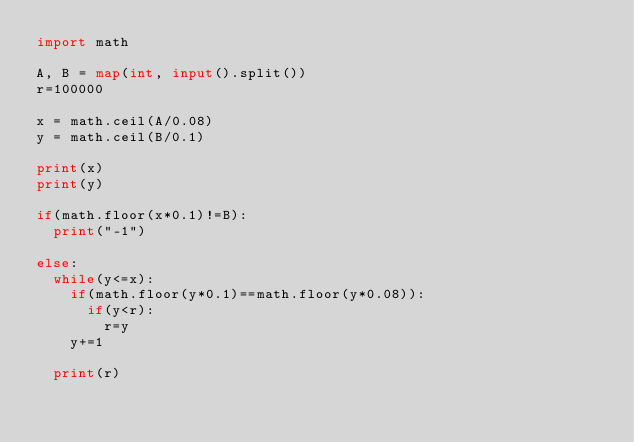<code> <loc_0><loc_0><loc_500><loc_500><_Python_>import math

A, B = map(int, input().split())
r=100000

x = math.ceil(A/0.08)
y = math.ceil(B/0.1)

print(x)
print(y)

if(math.floor(x*0.1)!=B):
  print("-1")

else:
  while(y<=x):
    if(math.floor(y*0.1)==math.floor(y*0.08)):
      if(y<r):
        r=y
    y+=1

  print(r)</code> 